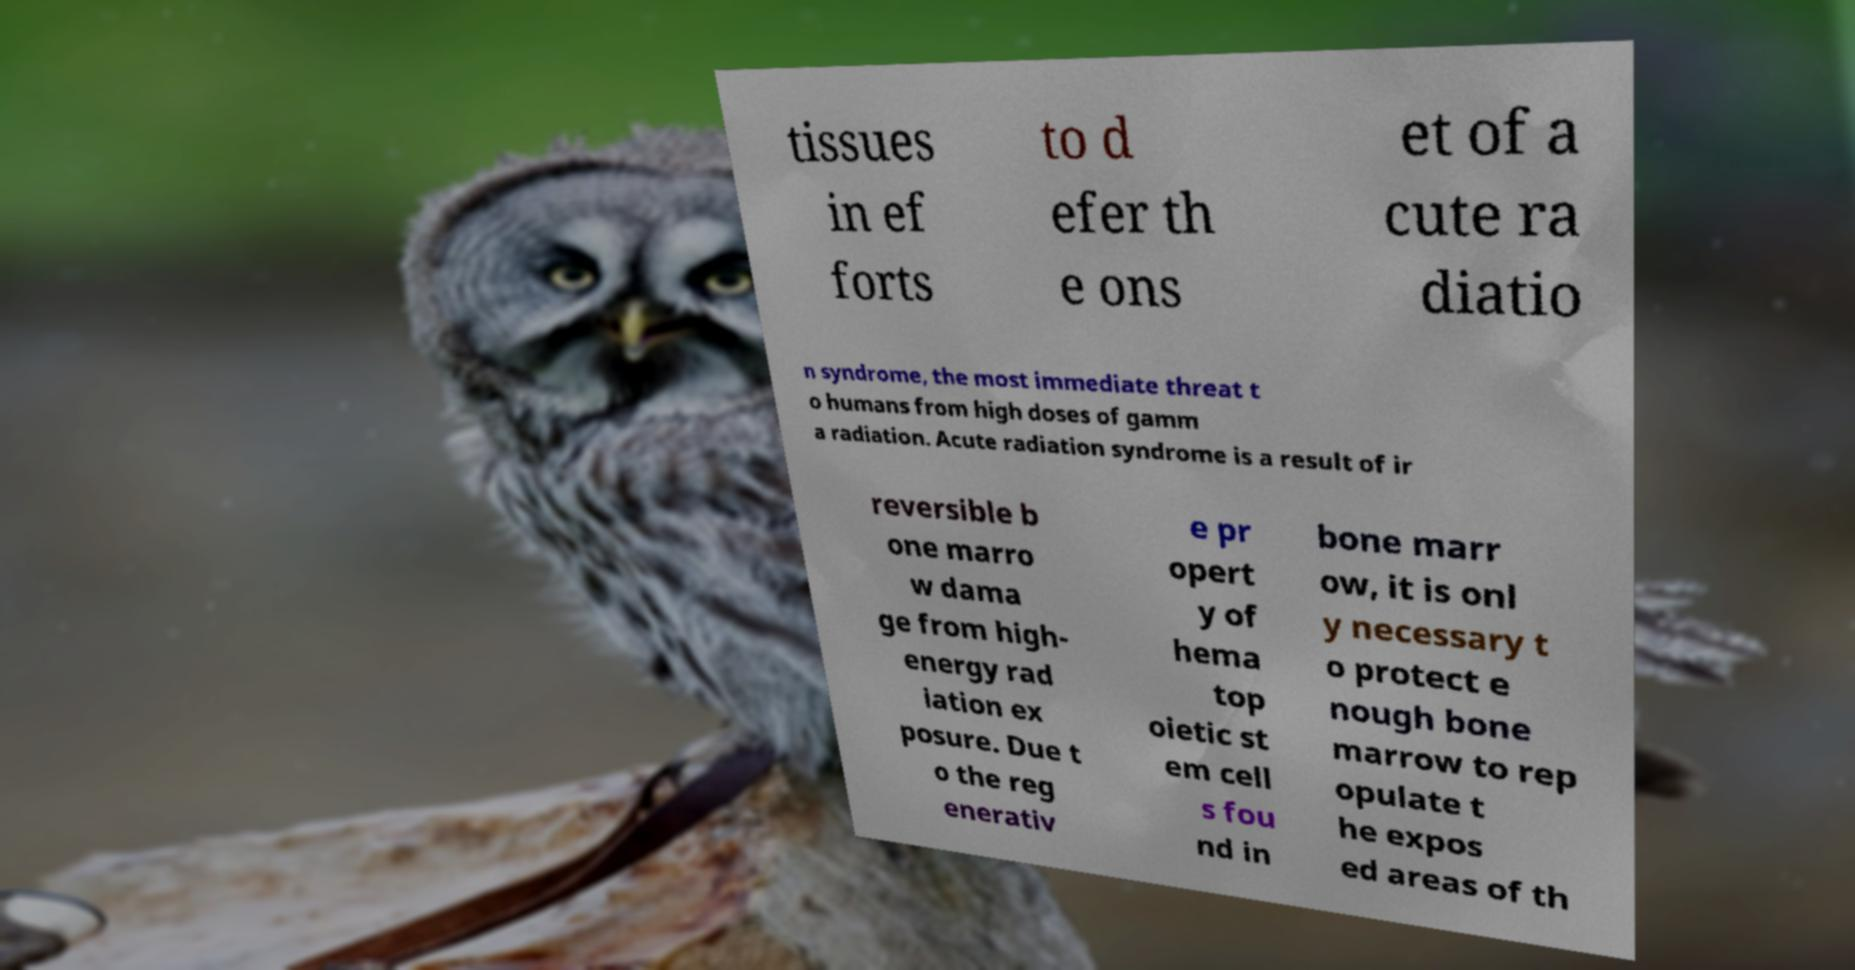Please identify and transcribe the text found in this image. tissues in ef forts to d efer th e ons et of a cute ra diatio n syndrome, the most immediate threat t o humans from high doses of gamm a radiation. Acute radiation syndrome is a result of ir reversible b one marro w dama ge from high- energy rad iation ex posure. Due t o the reg enerativ e pr opert y of hema top oietic st em cell s fou nd in bone marr ow, it is onl y necessary t o protect e nough bone marrow to rep opulate t he expos ed areas of th 